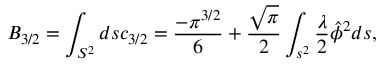<formula> <loc_0><loc_0><loc_500><loc_500>B _ { 3 / 2 } = \int _ { S ^ { 2 } } d s c _ { 3 / 2 } = \frac { - \pi ^ { 3 / 2 } } { 6 } + \frac { \sqrt { \pi } } { 2 } \int _ { s ^ { 2 } } \frac { \lambda } { 2 } \hat { \phi } ^ { 2 } d s ,</formula> 